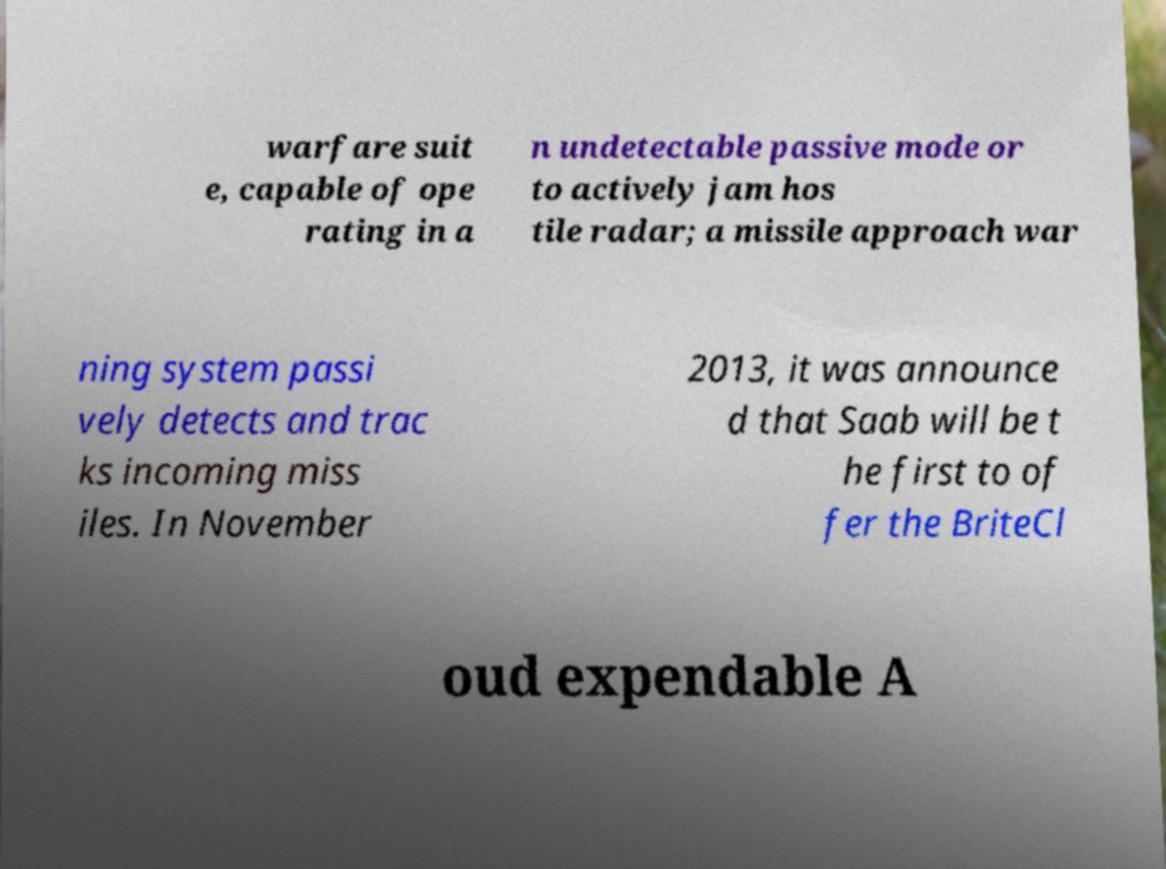Could you extract and type out the text from this image? warfare suit e, capable of ope rating in a n undetectable passive mode or to actively jam hos tile radar; a missile approach war ning system passi vely detects and trac ks incoming miss iles. In November 2013, it was announce d that Saab will be t he first to of fer the BriteCl oud expendable A 